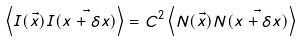<formula> <loc_0><loc_0><loc_500><loc_500>\left < I ( \vec { x } ) I ( \vec { x + \delta x } ) \right > = C ^ { 2 } \left < N ( \vec { x } ) N ( \vec { x + \delta x } ) \right ></formula> 